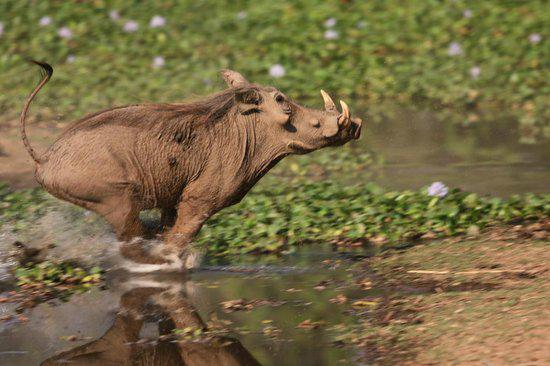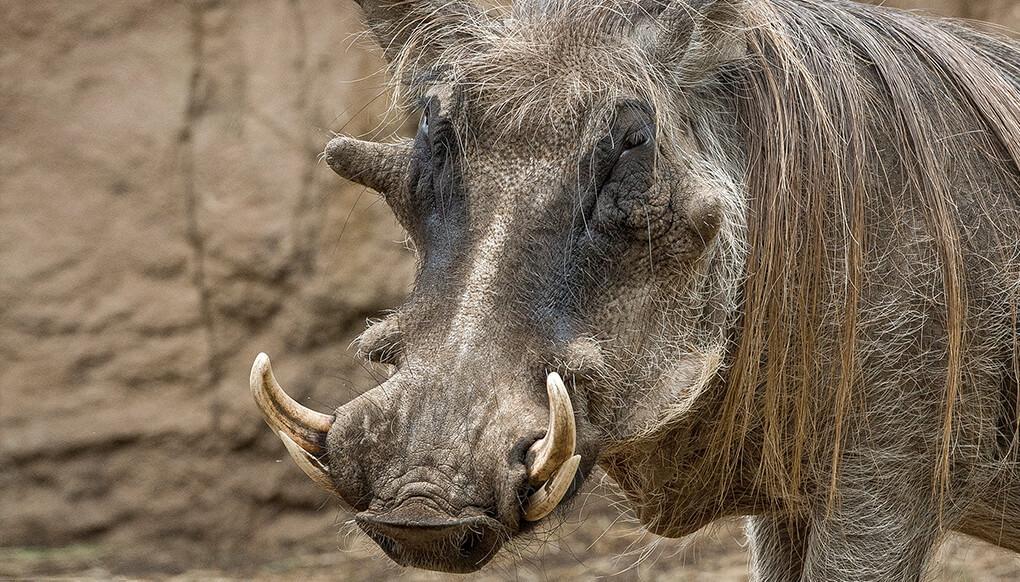The first image is the image on the left, the second image is the image on the right. Assess this claim about the two images: "The image on the left contains exactly two animals.". Correct or not? Answer yes or no. No. 